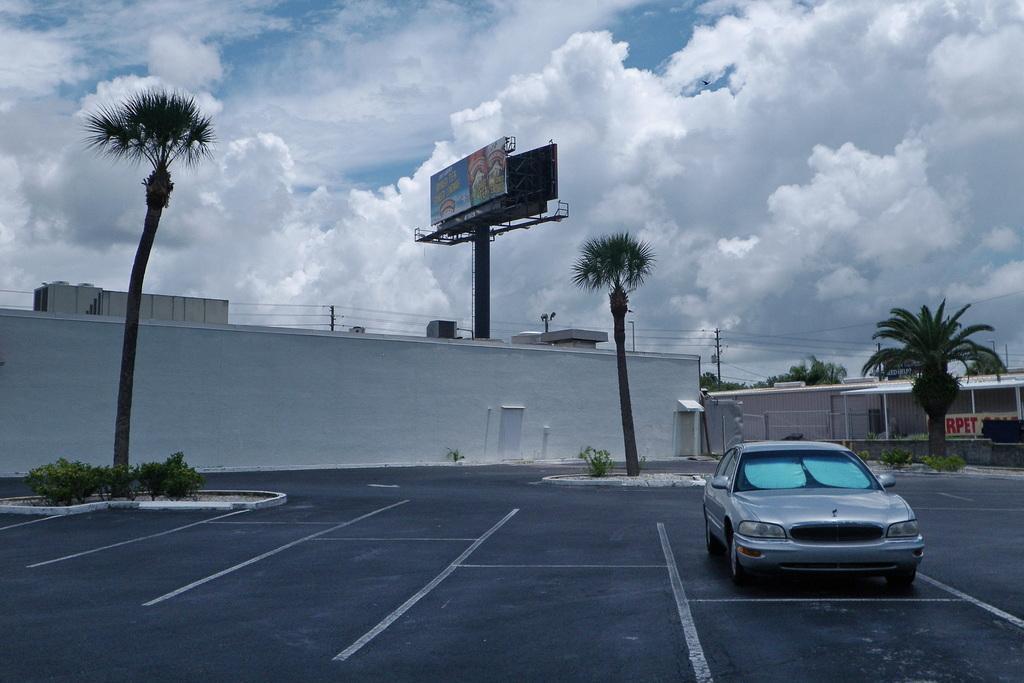Can you describe this image briefly? In this picture I can see buildings and a hoarding with some text and I can see trees and few poles and I can see a wall and few plants and I can see a blue cloudy sky and a car parked. 